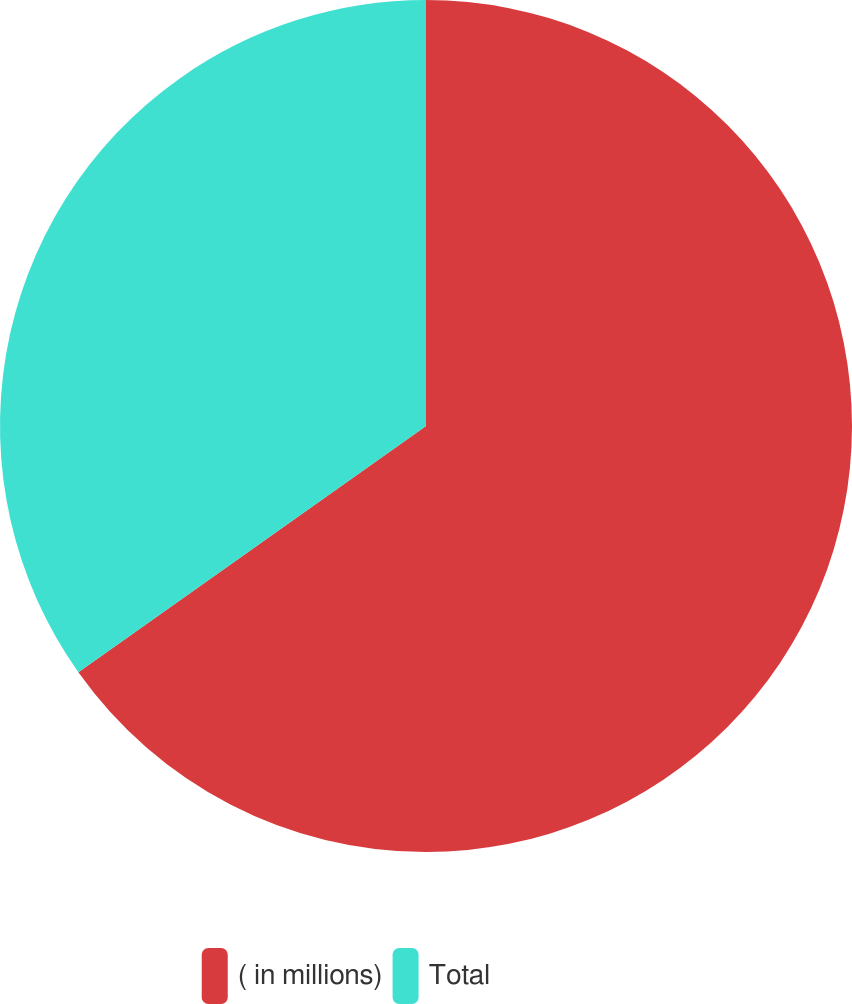<chart> <loc_0><loc_0><loc_500><loc_500><pie_chart><fcel>( in millions)<fcel>Total<nl><fcel>65.19%<fcel>34.81%<nl></chart> 